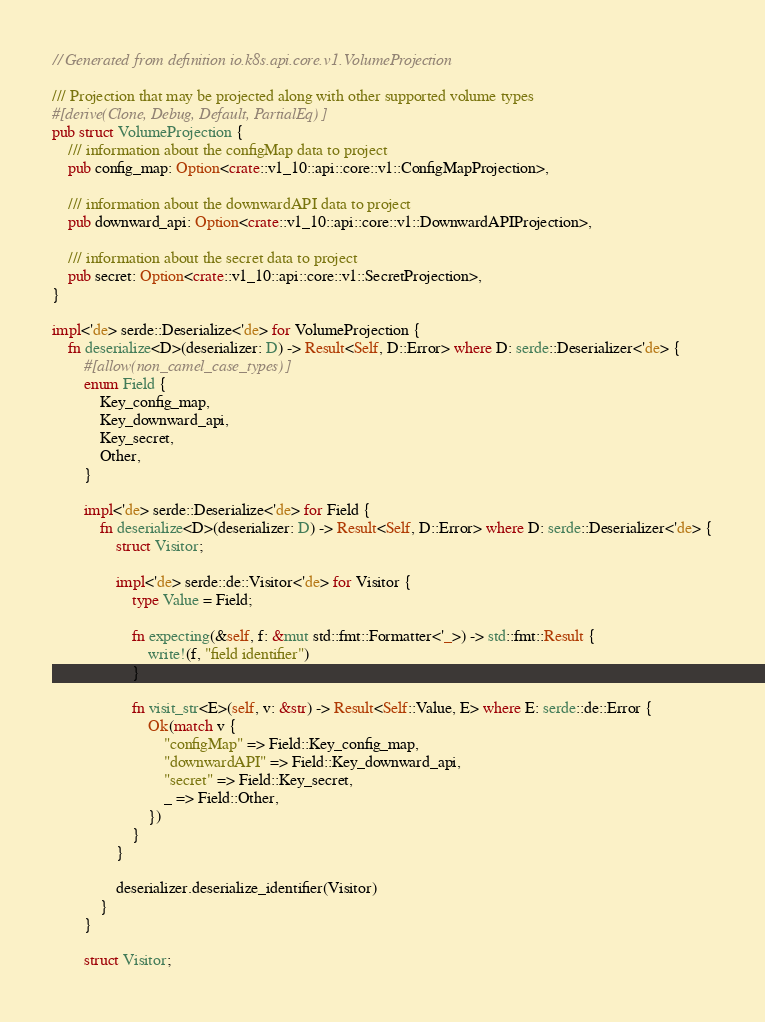Convert code to text. <code><loc_0><loc_0><loc_500><loc_500><_Rust_>// Generated from definition io.k8s.api.core.v1.VolumeProjection

/// Projection that may be projected along with other supported volume types
#[derive(Clone, Debug, Default, PartialEq)]
pub struct VolumeProjection {
    /// information about the configMap data to project
    pub config_map: Option<crate::v1_10::api::core::v1::ConfigMapProjection>,

    /// information about the downwardAPI data to project
    pub downward_api: Option<crate::v1_10::api::core::v1::DownwardAPIProjection>,

    /// information about the secret data to project
    pub secret: Option<crate::v1_10::api::core::v1::SecretProjection>,
}

impl<'de> serde::Deserialize<'de> for VolumeProjection {
    fn deserialize<D>(deserializer: D) -> Result<Self, D::Error> where D: serde::Deserializer<'de> {
        #[allow(non_camel_case_types)]
        enum Field {
            Key_config_map,
            Key_downward_api,
            Key_secret,
            Other,
        }

        impl<'de> serde::Deserialize<'de> for Field {
            fn deserialize<D>(deserializer: D) -> Result<Self, D::Error> where D: serde::Deserializer<'de> {
                struct Visitor;

                impl<'de> serde::de::Visitor<'de> for Visitor {
                    type Value = Field;

                    fn expecting(&self, f: &mut std::fmt::Formatter<'_>) -> std::fmt::Result {
                        write!(f, "field identifier")
                    }

                    fn visit_str<E>(self, v: &str) -> Result<Self::Value, E> where E: serde::de::Error {
                        Ok(match v {
                            "configMap" => Field::Key_config_map,
                            "downwardAPI" => Field::Key_downward_api,
                            "secret" => Field::Key_secret,
                            _ => Field::Other,
                        })
                    }
                }

                deserializer.deserialize_identifier(Visitor)
            }
        }

        struct Visitor;
</code> 